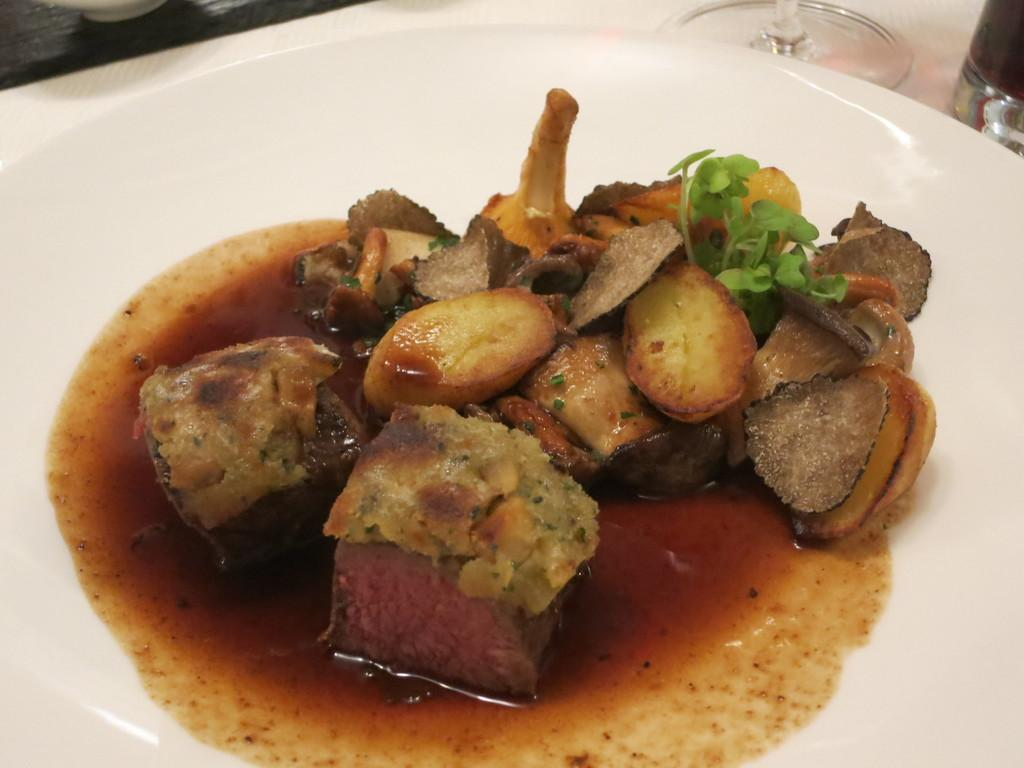What is the main object on the plate in the image? The facts do not specify the type of food item on the plate. Where is the plate located in the image? The plate is in the center of the image. What other dish is present in the image besides the plate? There is a bowl in the image. Are there any other containers on the table in the image? Yes, there is a vessel on the table. How does the calculator help with the food preparation in the image? There is no calculator present in the image, so it cannot help with food preparation. 